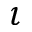<formula> <loc_0><loc_0><loc_500><loc_500>\iota</formula> 